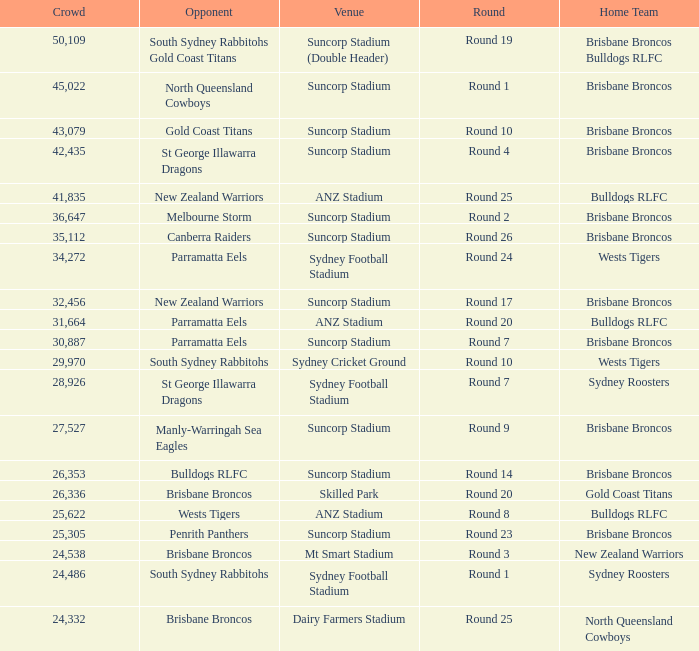What was the attendance at Round 9? 1.0. 